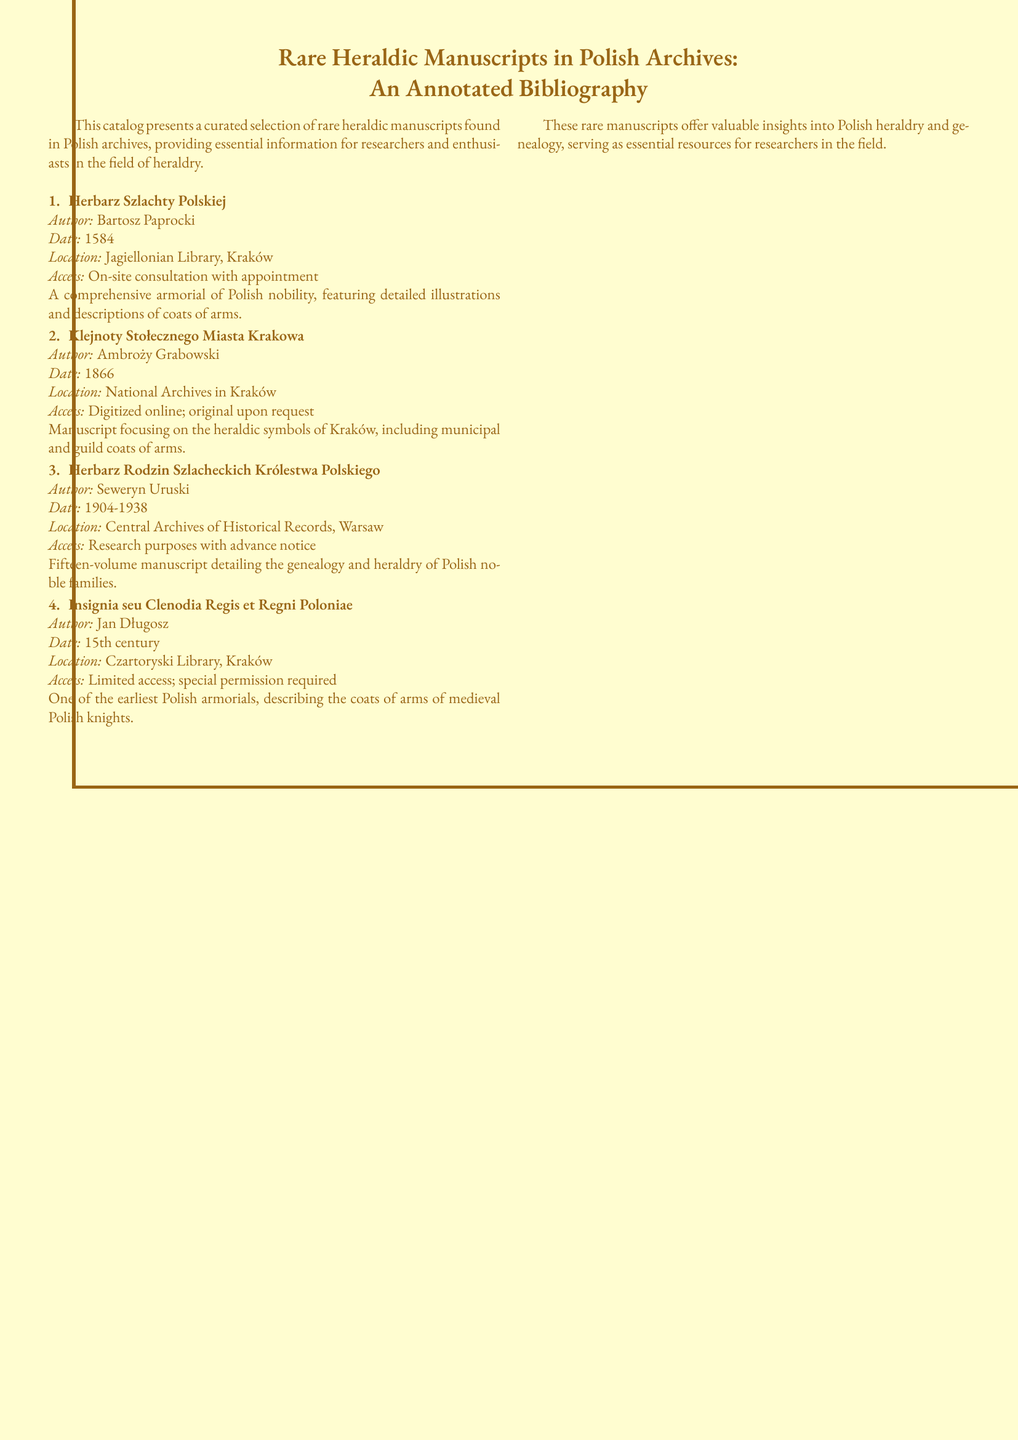What is the title of the first manuscript listed? The first manuscript is titled "Herbarz Szlachty Polskiej," which is noted in the catalog.
Answer: Herbarz Szlachty Polskiej Who is the author of "Klejnoty Stołecznego Miasta Krakowa"? The author mentioned in the document for this manuscript is Ambroży Grabowski.
Answer: Ambroży Grabowski In which year was "Herbarz Rodzin Szlacheckich Królestwa Polskiego" published? The publication year of this manuscript is noted as spanning from 1904 to 1938.
Answer: 1904-1938 Where can you access "Insignia seu Clenodia Regis et Regni Poloniae"? The location for this manuscript is identified as the Czartoryski Library, Kraków.
Answer: Czartoryski Library, Kraków What type of access is required to view "Herbarz Szlachty Polskiej"? The document specifies that access requires on-site consultation with an appointment.
Answer: On-site consultation with appointment Which manuscript focuses on heraldic symbols of Kraków? The manuscript that specifically addresses the heraldic symbols of Kraków is "Klejnoty Stołecznego Miasta Krakowa."
Answer: Klejnoty Stołecznego Miasta Krakowa How many volumes does "Herbarz Rodzin Szlacheckich Królestwa Polskiego" have? The catalog describes this manuscript as a fifteen-volume work.
Answer: Fifteen-volume What is the date of the manuscript "Insignia seu Clenodia Regis et Regni Poloniae"? The date indicated for this manuscript is the 15th century.
Answer: 15th century 